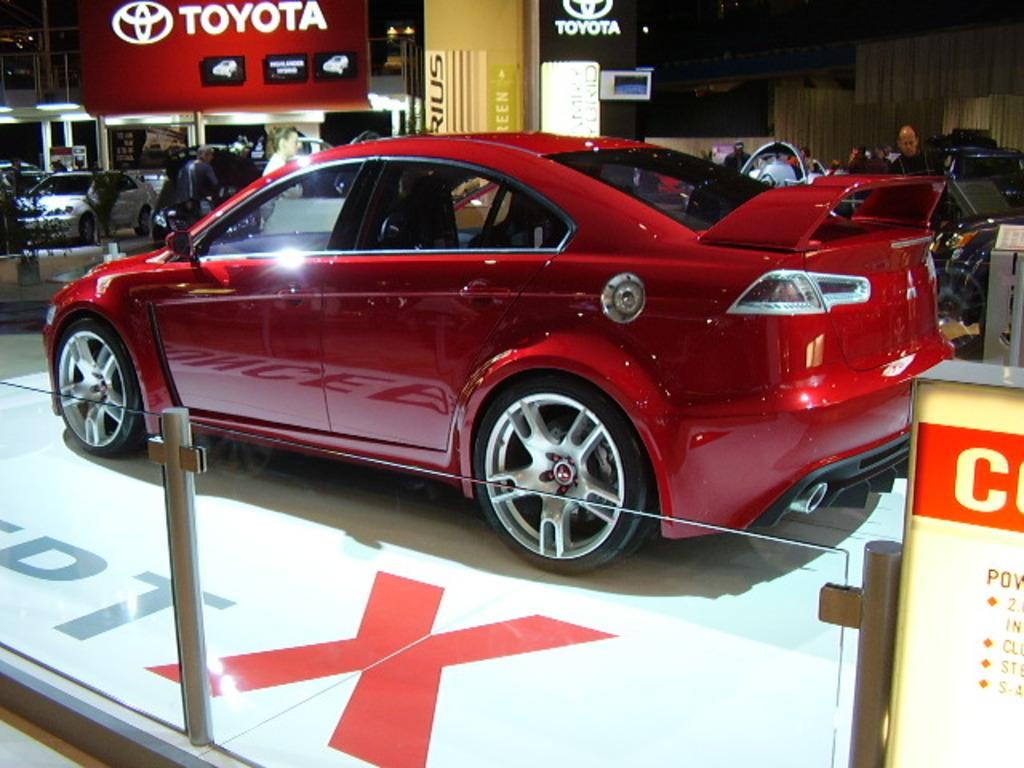Please provide a concise description of this image. In the foreground of this image, there is a red color car on the floor and at the bottom, there is a glass railing and it seems like a board on the right. In the background, there are few people standing, few cars on the floor and few boards and a pillar at the top and we can also see few lights. 